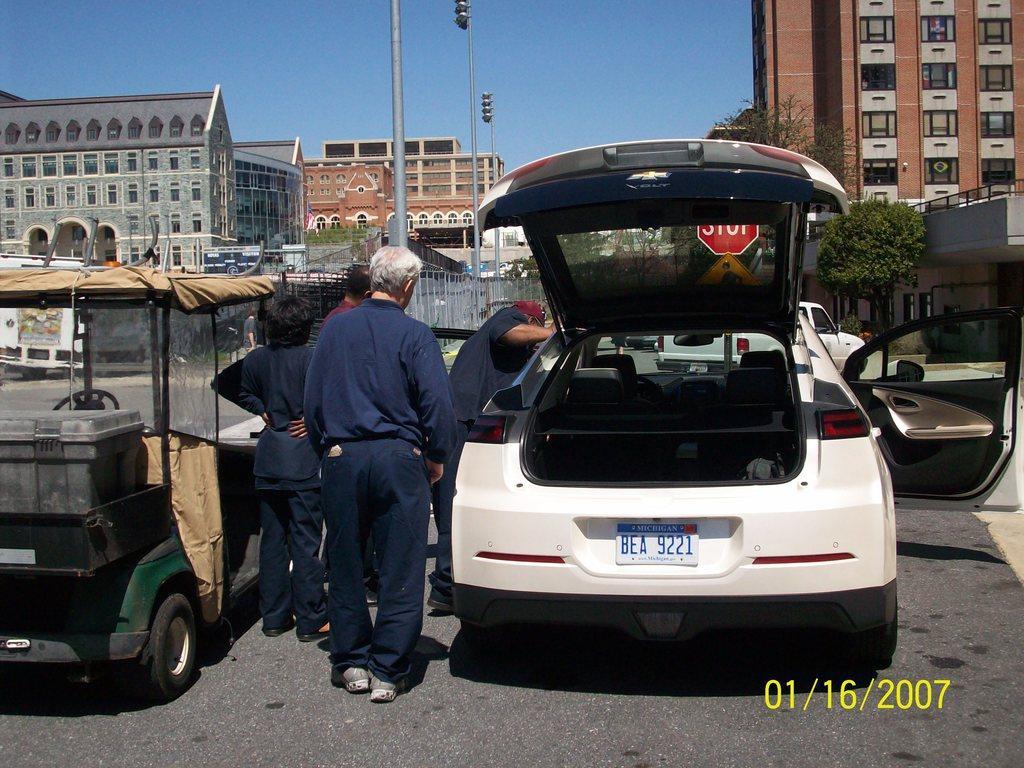Can you describe this image briefly? In this image we can see people and vehicles on the road. In the background, we can see a fence, buildings, poles, plants and a tree. At the top of the image, we can see the sky. There is a watermark in the right bottom of the image. 